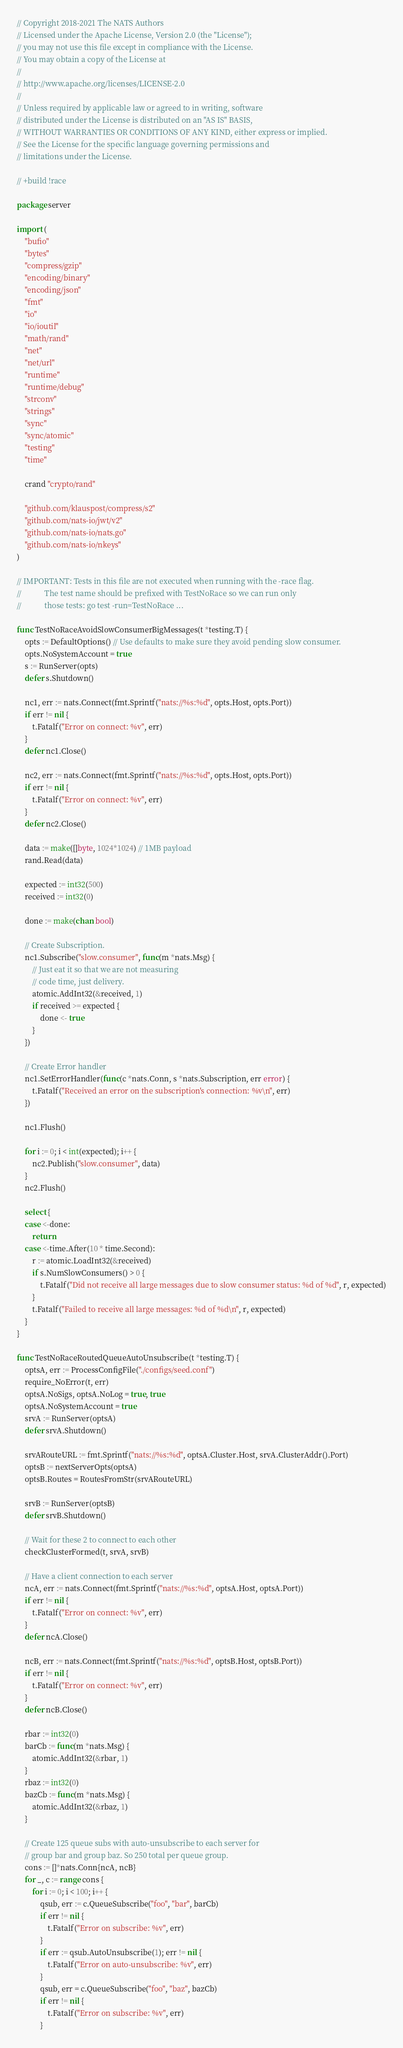Convert code to text. <code><loc_0><loc_0><loc_500><loc_500><_Go_>// Copyright 2018-2021 The NATS Authors
// Licensed under the Apache License, Version 2.0 (the "License");
// you may not use this file except in compliance with the License.
// You may obtain a copy of the License at
//
// http://www.apache.org/licenses/LICENSE-2.0
//
// Unless required by applicable law or agreed to in writing, software
// distributed under the License is distributed on an "AS IS" BASIS,
// WITHOUT WARRANTIES OR CONDITIONS OF ANY KIND, either express or implied.
// See the License for the specific language governing permissions and
// limitations under the License.

// +build !race

package server

import (
	"bufio"
	"bytes"
	"compress/gzip"
	"encoding/binary"
	"encoding/json"
	"fmt"
	"io"
	"io/ioutil"
	"math/rand"
	"net"
	"net/url"
	"runtime"
	"runtime/debug"
	"strconv"
	"strings"
	"sync"
	"sync/atomic"
	"testing"
	"time"

	crand "crypto/rand"

	"github.com/klauspost/compress/s2"
	"github.com/nats-io/jwt/v2"
	"github.com/nats-io/nats.go"
	"github.com/nats-io/nkeys"
)

// IMPORTANT: Tests in this file are not executed when running with the -race flag.
//            The test name should be prefixed with TestNoRace so we can run only
//            those tests: go test -run=TestNoRace ...

func TestNoRaceAvoidSlowConsumerBigMessages(t *testing.T) {
	opts := DefaultOptions() // Use defaults to make sure they avoid pending slow consumer.
	opts.NoSystemAccount = true
	s := RunServer(opts)
	defer s.Shutdown()

	nc1, err := nats.Connect(fmt.Sprintf("nats://%s:%d", opts.Host, opts.Port))
	if err != nil {
		t.Fatalf("Error on connect: %v", err)
	}
	defer nc1.Close()

	nc2, err := nats.Connect(fmt.Sprintf("nats://%s:%d", opts.Host, opts.Port))
	if err != nil {
		t.Fatalf("Error on connect: %v", err)
	}
	defer nc2.Close()

	data := make([]byte, 1024*1024) // 1MB payload
	rand.Read(data)

	expected := int32(500)
	received := int32(0)

	done := make(chan bool)

	// Create Subscription.
	nc1.Subscribe("slow.consumer", func(m *nats.Msg) {
		// Just eat it so that we are not measuring
		// code time, just delivery.
		atomic.AddInt32(&received, 1)
		if received >= expected {
			done <- true
		}
	})

	// Create Error handler
	nc1.SetErrorHandler(func(c *nats.Conn, s *nats.Subscription, err error) {
		t.Fatalf("Received an error on the subscription's connection: %v\n", err)
	})

	nc1.Flush()

	for i := 0; i < int(expected); i++ {
		nc2.Publish("slow.consumer", data)
	}
	nc2.Flush()

	select {
	case <-done:
		return
	case <-time.After(10 * time.Second):
		r := atomic.LoadInt32(&received)
		if s.NumSlowConsumers() > 0 {
			t.Fatalf("Did not receive all large messages due to slow consumer status: %d of %d", r, expected)
		}
		t.Fatalf("Failed to receive all large messages: %d of %d\n", r, expected)
	}
}

func TestNoRaceRoutedQueueAutoUnsubscribe(t *testing.T) {
	optsA, err := ProcessConfigFile("./configs/seed.conf")
	require_NoError(t, err)
	optsA.NoSigs, optsA.NoLog = true, true
	optsA.NoSystemAccount = true
	srvA := RunServer(optsA)
	defer srvA.Shutdown()

	srvARouteURL := fmt.Sprintf("nats://%s:%d", optsA.Cluster.Host, srvA.ClusterAddr().Port)
	optsB := nextServerOpts(optsA)
	optsB.Routes = RoutesFromStr(srvARouteURL)

	srvB := RunServer(optsB)
	defer srvB.Shutdown()

	// Wait for these 2 to connect to each other
	checkClusterFormed(t, srvA, srvB)

	// Have a client connection to each server
	ncA, err := nats.Connect(fmt.Sprintf("nats://%s:%d", optsA.Host, optsA.Port))
	if err != nil {
		t.Fatalf("Error on connect: %v", err)
	}
	defer ncA.Close()

	ncB, err := nats.Connect(fmt.Sprintf("nats://%s:%d", optsB.Host, optsB.Port))
	if err != nil {
		t.Fatalf("Error on connect: %v", err)
	}
	defer ncB.Close()

	rbar := int32(0)
	barCb := func(m *nats.Msg) {
		atomic.AddInt32(&rbar, 1)
	}
	rbaz := int32(0)
	bazCb := func(m *nats.Msg) {
		atomic.AddInt32(&rbaz, 1)
	}

	// Create 125 queue subs with auto-unsubscribe to each server for
	// group bar and group baz. So 250 total per queue group.
	cons := []*nats.Conn{ncA, ncB}
	for _, c := range cons {
		for i := 0; i < 100; i++ {
			qsub, err := c.QueueSubscribe("foo", "bar", barCb)
			if err != nil {
				t.Fatalf("Error on subscribe: %v", err)
			}
			if err := qsub.AutoUnsubscribe(1); err != nil {
				t.Fatalf("Error on auto-unsubscribe: %v", err)
			}
			qsub, err = c.QueueSubscribe("foo", "baz", bazCb)
			if err != nil {
				t.Fatalf("Error on subscribe: %v", err)
			}</code> 